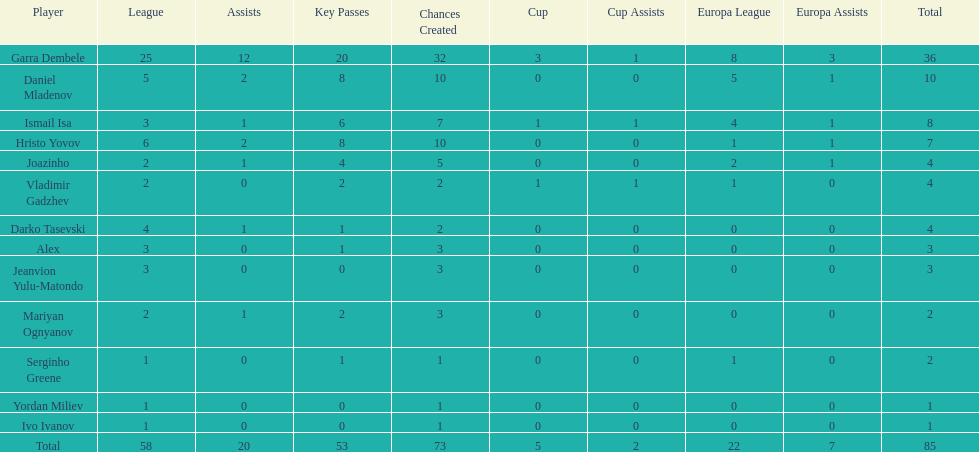Who are the individuals possessing at least 4 in the europa league? Garra Dembele, Daniel Mladenov, Ismail Isa. 